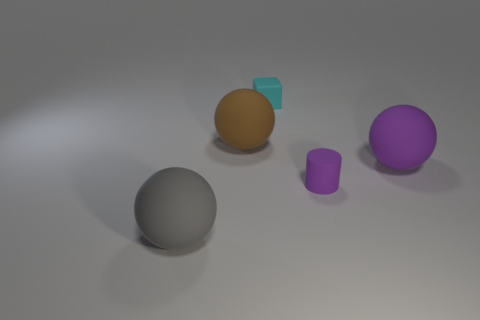Subtract all gray spheres. How many spheres are left? 2 Add 5 tiny rubber cubes. How many objects exist? 10 Subtract 0 green cylinders. How many objects are left? 5 Subtract all cubes. How many objects are left? 4 Subtract 1 cylinders. How many cylinders are left? 0 Subtract all brown spheres. Subtract all blue cylinders. How many spheres are left? 2 Subtract all big gray objects. Subtract all gray matte objects. How many objects are left? 3 Add 2 gray balls. How many gray balls are left? 3 Add 5 tiny cyan objects. How many tiny cyan objects exist? 6 